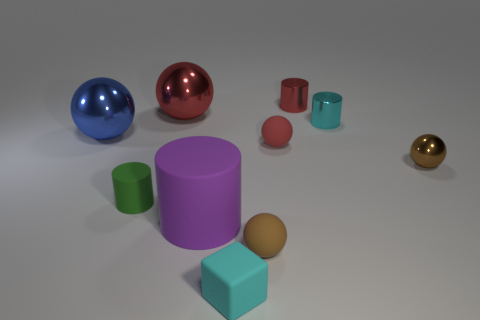Is the color of the small block the same as the shiny cylinder in front of the large red shiny object?
Offer a terse response. Yes. Are there any metallic cylinders of the same color as the small rubber cube?
Give a very brief answer. Yes. The small metal thing that is the same color as the small cube is what shape?
Your answer should be compact. Cylinder. Is the color of the tiny rubber ball that is in front of the tiny green matte thing the same as the small shiny sphere?
Keep it short and to the point. Yes. What number of things are matte blocks or big shiny cylinders?
Offer a terse response. 1. How many large things are behind the tiny matte ball in front of the small red thing that is to the left of the red cylinder?
Your answer should be very brief. 3. Is there any other thing of the same color as the big matte thing?
Provide a succinct answer. No. Is the color of the small matte object that is behind the brown shiny ball the same as the thing that is behind the large red metallic object?
Offer a very short reply. Yes. Are there more small metallic spheres that are to the right of the blue ball than cyan things to the left of the rubber cube?
Ensure brevity in your answer.  Yes. What is the material of the tiny cyan block?
Give a very brief answer. Rubber. 